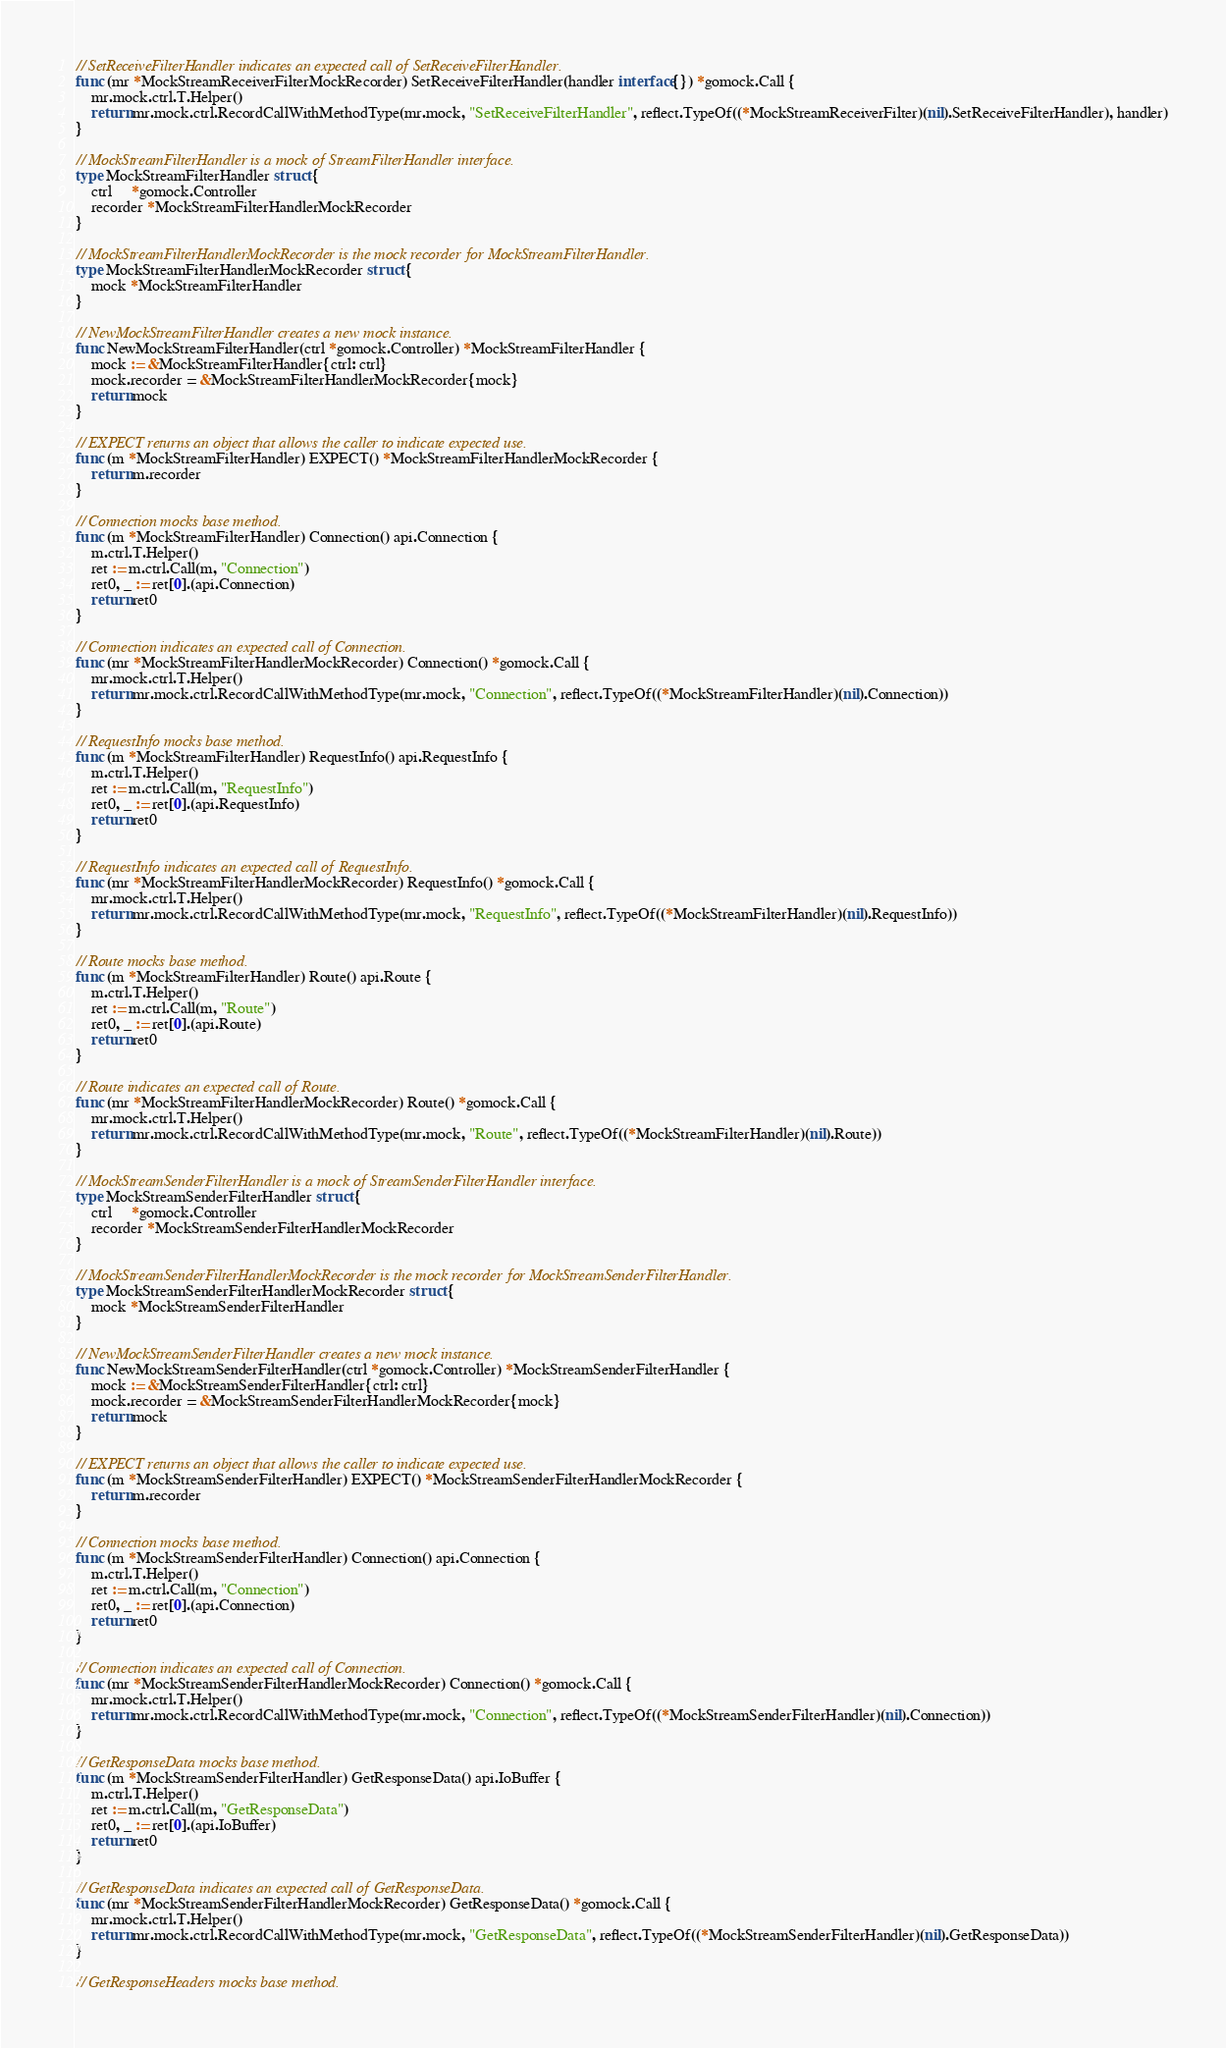<code> <loc_0><loc_0><loc_500><loc_500><_Go_>
// SetReceiveFilterHandler indicates an expected call of SetReceiveFilterHandler.
func (mr *MockStreamReceiverFilterMockRecorder) SetReceiveFilterHandler(handler interface{}) *gomock.Call {
	mr.mock.ctrl.T.Helper()
	return mr.mock.ctrl.RecordCallWithMethodType(mr.mock, "SetReceiveFilterHandler", reflect.TypeOf((*MockStreamReceiverFilter)(nil).SetReceiveFilterHandler), handler)
}

// MockStreamFilterHandler is a mock of StreamFilterHandler interface.
type MockStreamFilterHandler struct {
	ctrl     *gomock.Controller
	recorder *MockStreamFilterHandlerMockRecorder
}

// MockStreamFilterHandlerMockRecorder is the mock recorder for MockStreamFilterHandler.
type MockStreamFilterHandlerMockRecorder struct {
	mock *MockStreamFilterHandler
}

// NewMockStreamFilterHandler creates a new mock instance.
func NewMockStreamFilterHandler(ctrl *gomock.Controller) *MockStreamFilterHandler {
	mock := &MockStreamFilterHandler{ctrl: ctrl}
	mock.recorder = &MockStreamFilterHandlerMockRecorder{mock}
	return mock
}

// EXPECT returns an object that allows the caller to indicate expected use.
func (m *MockStreamFilterHandler) EXPECT() *MockStreamFilterHandlerMockRecorder {
	return m.recorder
}

// Connection mocks base method.
func (m *MockStreamFilterHandler) Connection() api.Connection {
	m.ctrl.T.Helper()
	ret := m.ctrl.Call(m, "Connection")
	ret0, _ := ret[0].(api.Connection)
	return ret0
}

// Connection indicates an expected call of Connection.
func (mr *MockStreamFilterHandlerMockRecorder) Connection() *gomock.Call {
	mr.mock.ctrl.T.Helper()
	return mr.mock.ctrl.RecordCallWithMethodType(mr.mock, "Connection", reflect.TypeOf((*MockStreamFilterHandler)(nil).Connection))
}

// RequestInfo mocks base method.
func (m *MockStreamFilterHandler) RequestInfo() api.RequestInfo {
	m.ctrl.T.Helper()
	ret := m.ctrl.Call(m, "RequestInfo")
	ret0, _ := ret[0].(api.RequestInfo)
	return ret0
}

// RequestInfo indicates an expected call of RequestInfo.
func (mr *MockStreamFilterHandlerMockRecorder) RequestInfo() *gomock.Call {
	mr.mock.ctrl.T.Helper()
	return mr.mock.ctrl.RecordCallWithMethodType(mr.mock, "RequestInfo", reflect.TypeOf((*MockStreamFilterHandler)(nil).RequestInfo))
}

// Route mocks base method.
func (m *MockStreamFilterHandler) Route() api.Route {
	m.ctrl.T.Helper()
	ret := m.ctrl.Call(m, "Route")
	ret0, _ := ret[0].(api.Route)
	return ret0
}

// Route indicates an expected call of Route.
func (mr *MockStreamFilterHandlerMockRecorder) Route() *gomock.Call {
	mr.mock.ctrl.T.Helper()
	return mr.mock.ctrl.RecordCallWithMethodType(mr.mock, "Route", reflect.TypeOf((*MockStreamFilterHandler)(nil).Route))
}

// MockStreamSenderFilterHandler is a mock of StreamSenderFilterHandler interface.
type MockStreamSenderFilterHandler struct {
	ctrl     *gomock.Controller
	recorder *MockStreamSenderFilterHandlerMockRecorder
}

// MockStreamSenderFilterHandlerMockRecorder is the mock recorder for MockStreamSenderFilterHandler.
type MockStreamSenderFilterHandlerMockRecorder struct {
	mock *MockStreamSenderFilterHandler
}

// NewMockStreamSenderFilterHandler creates a new mock instance.
func NewMockStreamSenderFilterHandler(ctrl *gomock.Controller) *MockStreamSenderFilterHandler {
	mock := &MockStreamSenderFilterHandler{ctrl: ctrl}
	mock.recorder = &MockStreamSenderFilterHandlerMockRecorder{mock}
	return mock
}

// EXPECT returns an object that allows the caller to indicate expected use.
func (m *MockStreamSenderFilterHandler) EXPECT() *MockStreamSenderFilterHandlerMockRecorder {
	return m.recorder
}

// Connection mocks base method.
func (m *MockStreamSenderFilterHandler) Connection() api.Connection {
	m.ctrl.T.Helper()
	ret := m.ctrl.Call(m, "Connection")
	ret0, _ := ret[0].(api.Connection)
	return ret0
}

// Connection indicates an expected call of Connection.
func (mr *MockStreamSenderFilterHandlerMockRecorder) Connection() *gomock.Call {
	mr.mock.ctrl.T.Helper()
	return mr.mock.ctrl.RecordCallWithMethodType(mr.mock, "Connection", reflect.TypeOf((*MockStreamSenderFilterHandler)(nil).Connection))
}

// GetResponseData mocks base method.
func (m *MockStreamSenderFilterHandler) GetResponseData() api.IoBuffer {
	m.ctrl.T.Helper()
	ret := m.ctrl.Call(m, "GetResponseData")
	ret0, _ := ret[0].(api.IoBuffer)
	return ret0
}

// GetResponseData indicates an expected call of GetResponseData.
func (mr *MockStreamSenderFilterHandlerMockRecorder) GetResponseData() *gomock.Call {
	mr.mock.ctrl.T.Helper()
	return mr.mock.ctrl.RecordCallWithMethodType(mr.mock, "GetResponseData", reflect.TypeOf((*MockStreamSenderFilterHandler)(nil).GetResponseData))
}

// GetResponseHeaders mocks base method.</code> 